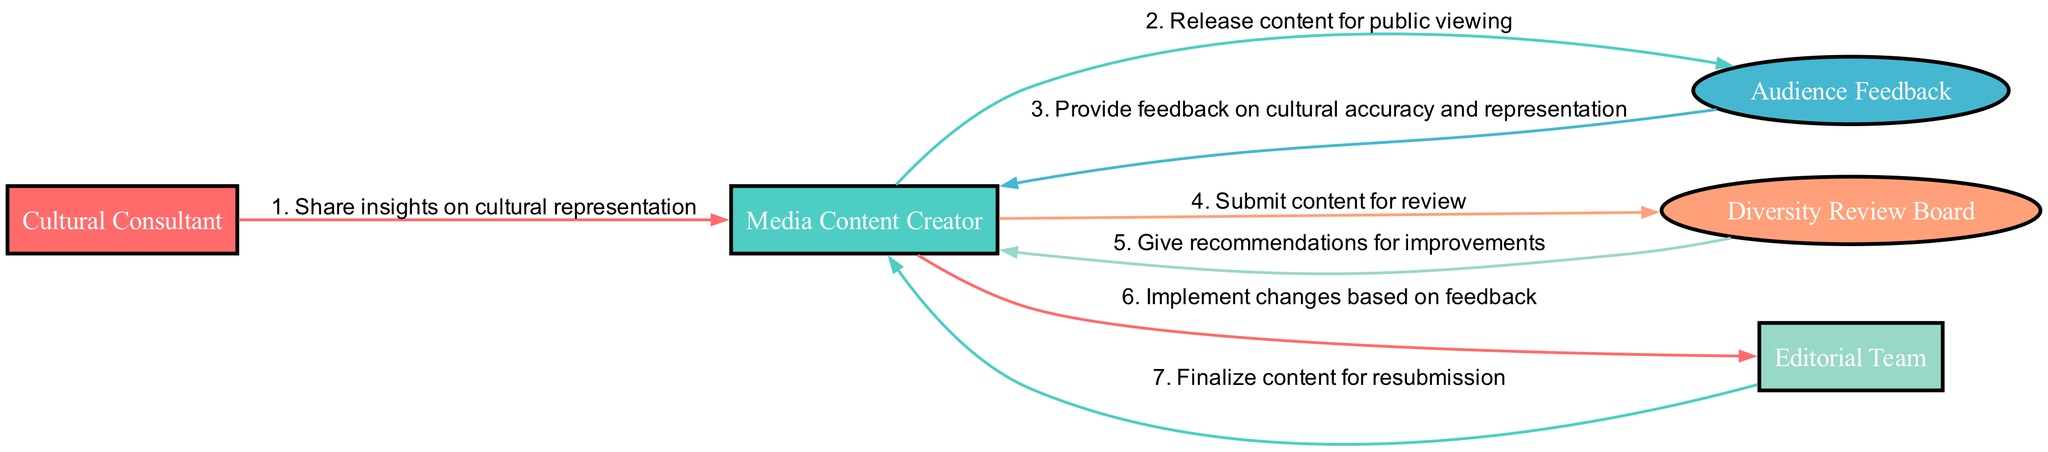What is the first action in the feedback loop? The feedback loop begins with the Cultural Consultant sharing insights on cultural representation with the Media Content Creator. This is the first step shown in the diagram.
Answer: Share insights on cultural representation How many total participants are there in the diagram? The diagram includes five distinct participants: Cultural Consultant, Media Content Creator, Audience Feedback, Diversity Review Board, and Editorial Team. Counting them gives us a total of five participants.
Answer: 5 What action does the Media Content Creator take after receiving feedback? After the Media Content Creator receives feedback on cultural accuracy and representation from the Audience Feedback, the next step is to submit the content for review to the Diversity Review Board.
Answer: Submit content for review Which participant gives recommendations for improvements? The Diversity Review Board is responsible for providing recommendations for improvements after reviewing the submitted content. This is explicitly stated in the sequence of actions in the diagram.
Answer: Diversity Review Board What follows the action of implementing changes based on feedback? After the Media Content Creator implements changes based on the feedback, the next action shown in the diagram is for the Editorial Team to finalize the content for resubmission. This follows directly in the sequence.
Answer: Finalize content for resubmission How many actions take place between the Cultural Consultant and the Editorial Team? There are three actions that occur in sequence between these two participants: sharing insights, submitting content for review, and implementing changes based on feedback. These actions create a flow from the Cultural Consultant to the Media Content Creator, and then to the Editorial Team, totaling three steps in this process.
Answer: 3 What action comes before receiving audience feedback? The action that comes immediately before receiving audience feedback is the release of content for public viewing by the Media Content Creator, which sets the stage for the audience to provide their input.
Answer: Release content for public viewing Which participant is last in the sequence of actions? The Editorial Team is the last participant involved in the sequence. Their final action in the diagram indicates that they complete their role in the feedback loop by finalizing the content for resubmission after changes are implemented.
Answer: Editorial Team 